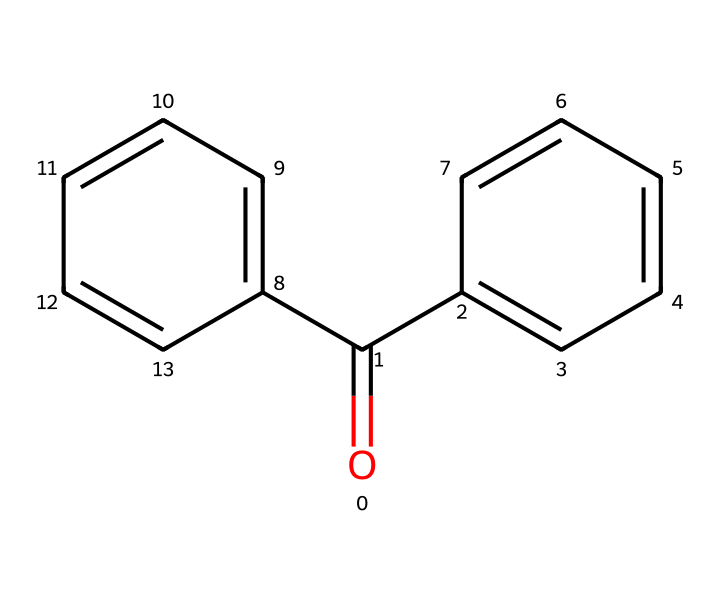What is the common name for this chemical? The chemical shown has the SMILES structure related to benzophenone, which is the common name for this compound.
Answer: benzophenone How many carbon atoms are in the structure? Analyzing the SMILES representation, I count a total of 13 carbon atoms (denoted by the 'C' in the structure).
Answer: 13 What functional group is present in this compound? The structure contains a carbonyl group (C=O), which classifies it as a ketone.
Answer: ketone How many rings are present in the structure? The SMILES representation indicates there are two aromatic rings (C1=CC=CC=C1 and C2=CC=CC=C2) in the compound, making a total of 2 rings.
Answer: 2 What is the molecular formula derived from the structure? By assessing the atoms present in the SMILES notation, this compound has a molecular formula of C13H10O, consisting of 13 carbons, 10 hydrogens, and 1 oxygen.
Answer: C13H10O What property makes benzophenone useful in sunscreens? The structure contains a carbonyl group that absorbs UV light, making it effective at blocking UV radiation, which is essential in sunscreens.
Answer: absorbs UV light How does the structure reflect its use in UV-cured inks? The double bonds in the aromatic rings enable the compound to undergo photopolymerization, which is crucial for curing inks when exposed to UV light.
Answer: photopolymerization 